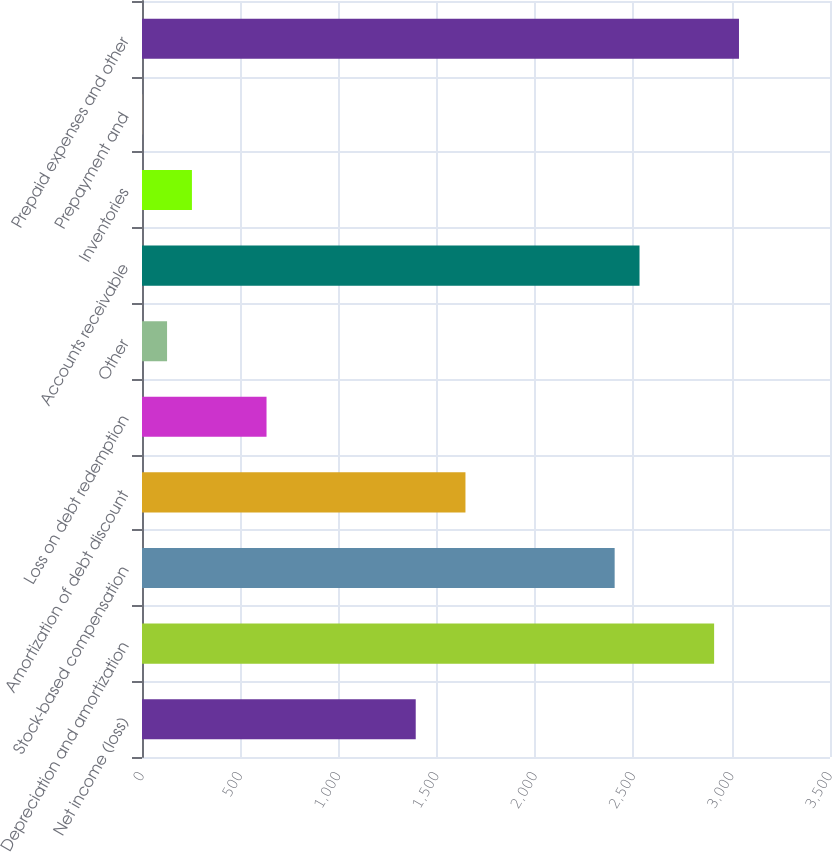<chart> <loc_0><loc_0><loc_500><loc_500><bar_chart><fcel>Net income (loss)<fcel>Depreciation and amortization<fcel>Stock-based compensation<fcel>Amortization of debt discount<fcel>Loss on debt redemption<fcel>Other<fcel>Accounts receivable<fcel>Inventories<fcel>Prepayment and<fcel>Prepaid expenses and other<nl><fcel>1392.5<fcel>2910.5<fcel>2404.5<fcel>1645.5<fcel>633.5<fcel>127.5<fcel>2531<fcel>254<fcel>1<fcel>3037<nl></chart> 